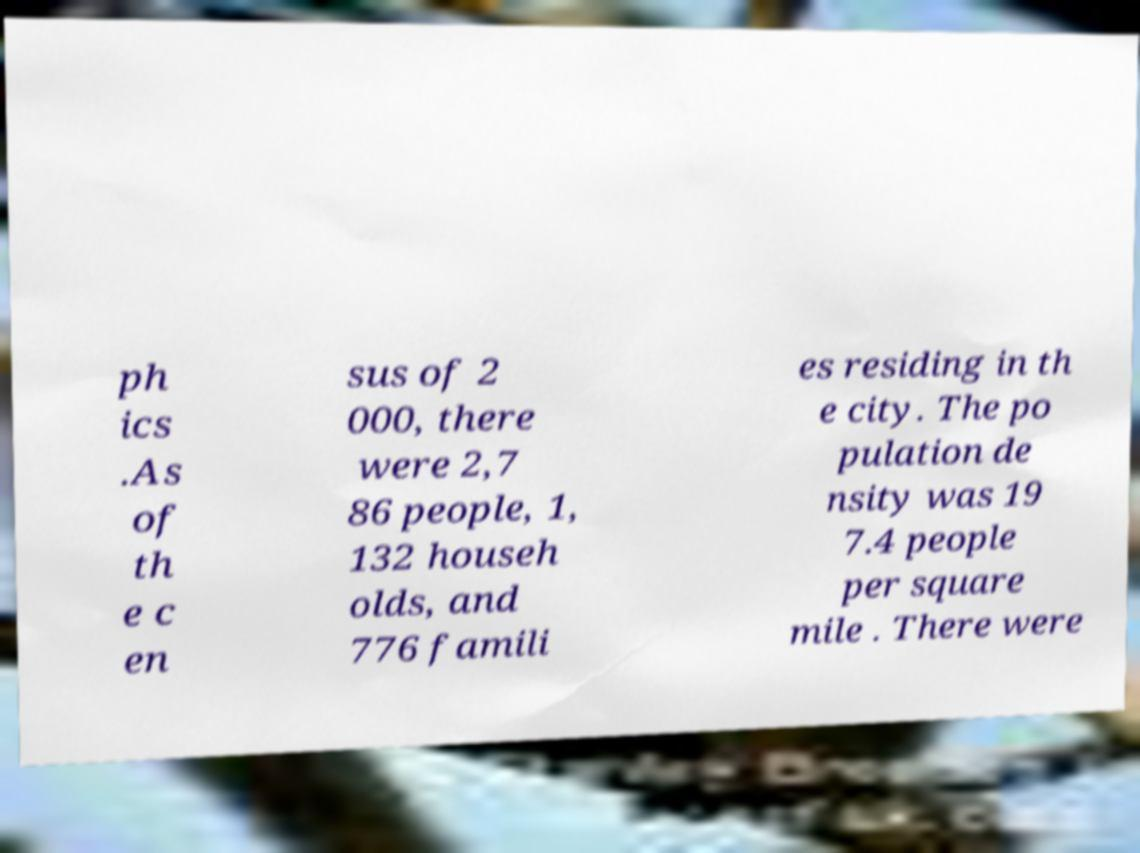There's text embedded in this image that I need extracted. Can you transcribe it verbatim? ph ics .As of th e c en sus of 2 000, there were 2,7 86 people, 1, 132 househ olds, and 776 famili es residing in th e city. The po pulation de nsity was 19 7.4 people per square mile . There were 